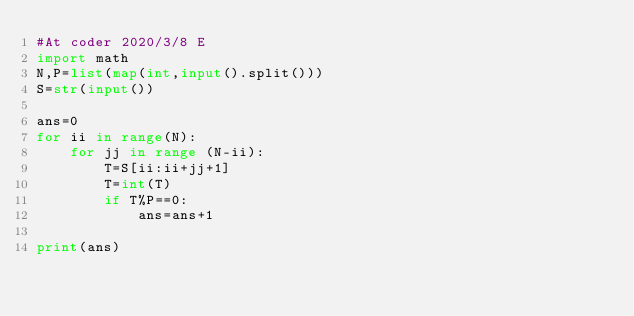<code> <loc_0><loc_0><loc_500><loc_500><_Python_>#At coder 2020/3/8 E
import math
N,P=list(map(int,input().split())) 
S=str(input())

ans=0
for ii in range(N):
    for jj in range (N-ii):
        T=S[ii:ii+jj+1]
        T=int(T)
        if T%P==0:
            ans=ans+1

print(ans)</code> 